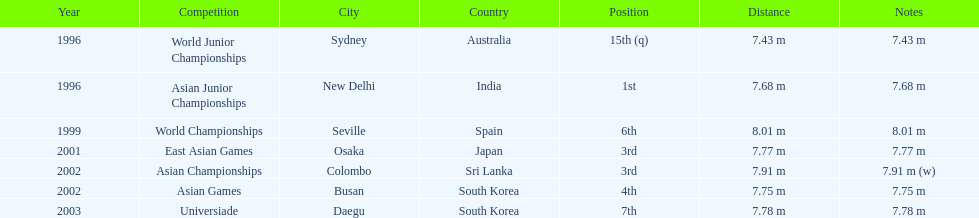What is the difference between the number of times the position of third was achieved and the number of times the position of first was achieved? 1. 